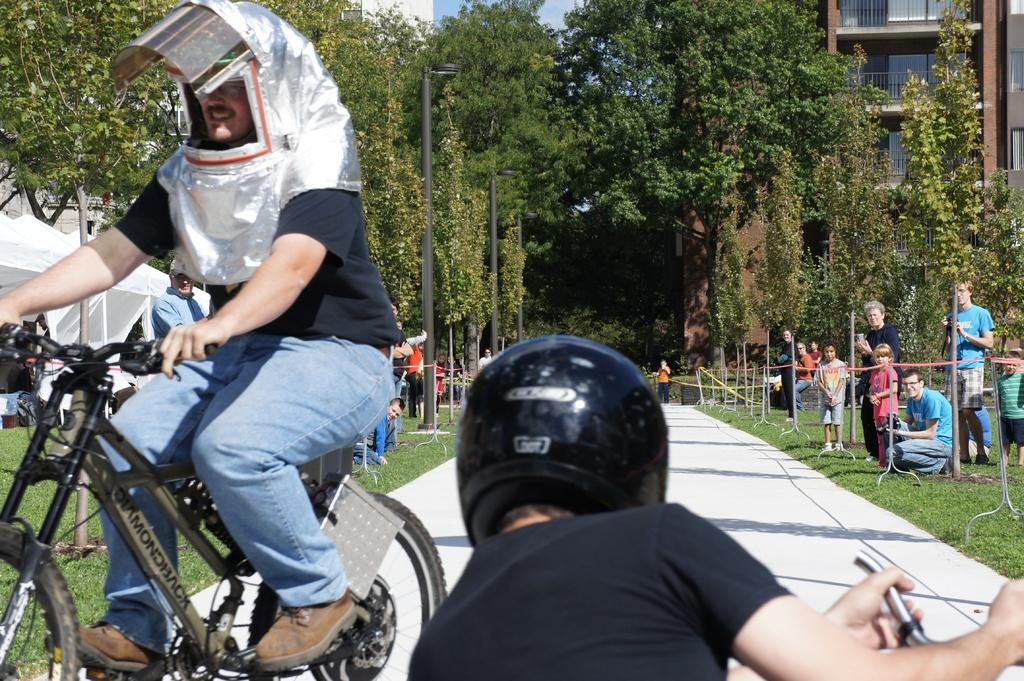What is the man in the image wearing on his head? The man in the image is wearing a helmet. What is the man doing while wearing the helmet? The man is riding a bicycle. Are there any other cyclists in the image? Yes, there is another man riding a bicycle in the image. What else can be seen in the image besides the cyclists? People are standing and watching the cyclists, trees are visible, and there is a building in the image. What type of horses are participating in the society event in the image? There are no horses or society events present in the image; it features two men riding bicycles and people watching. 